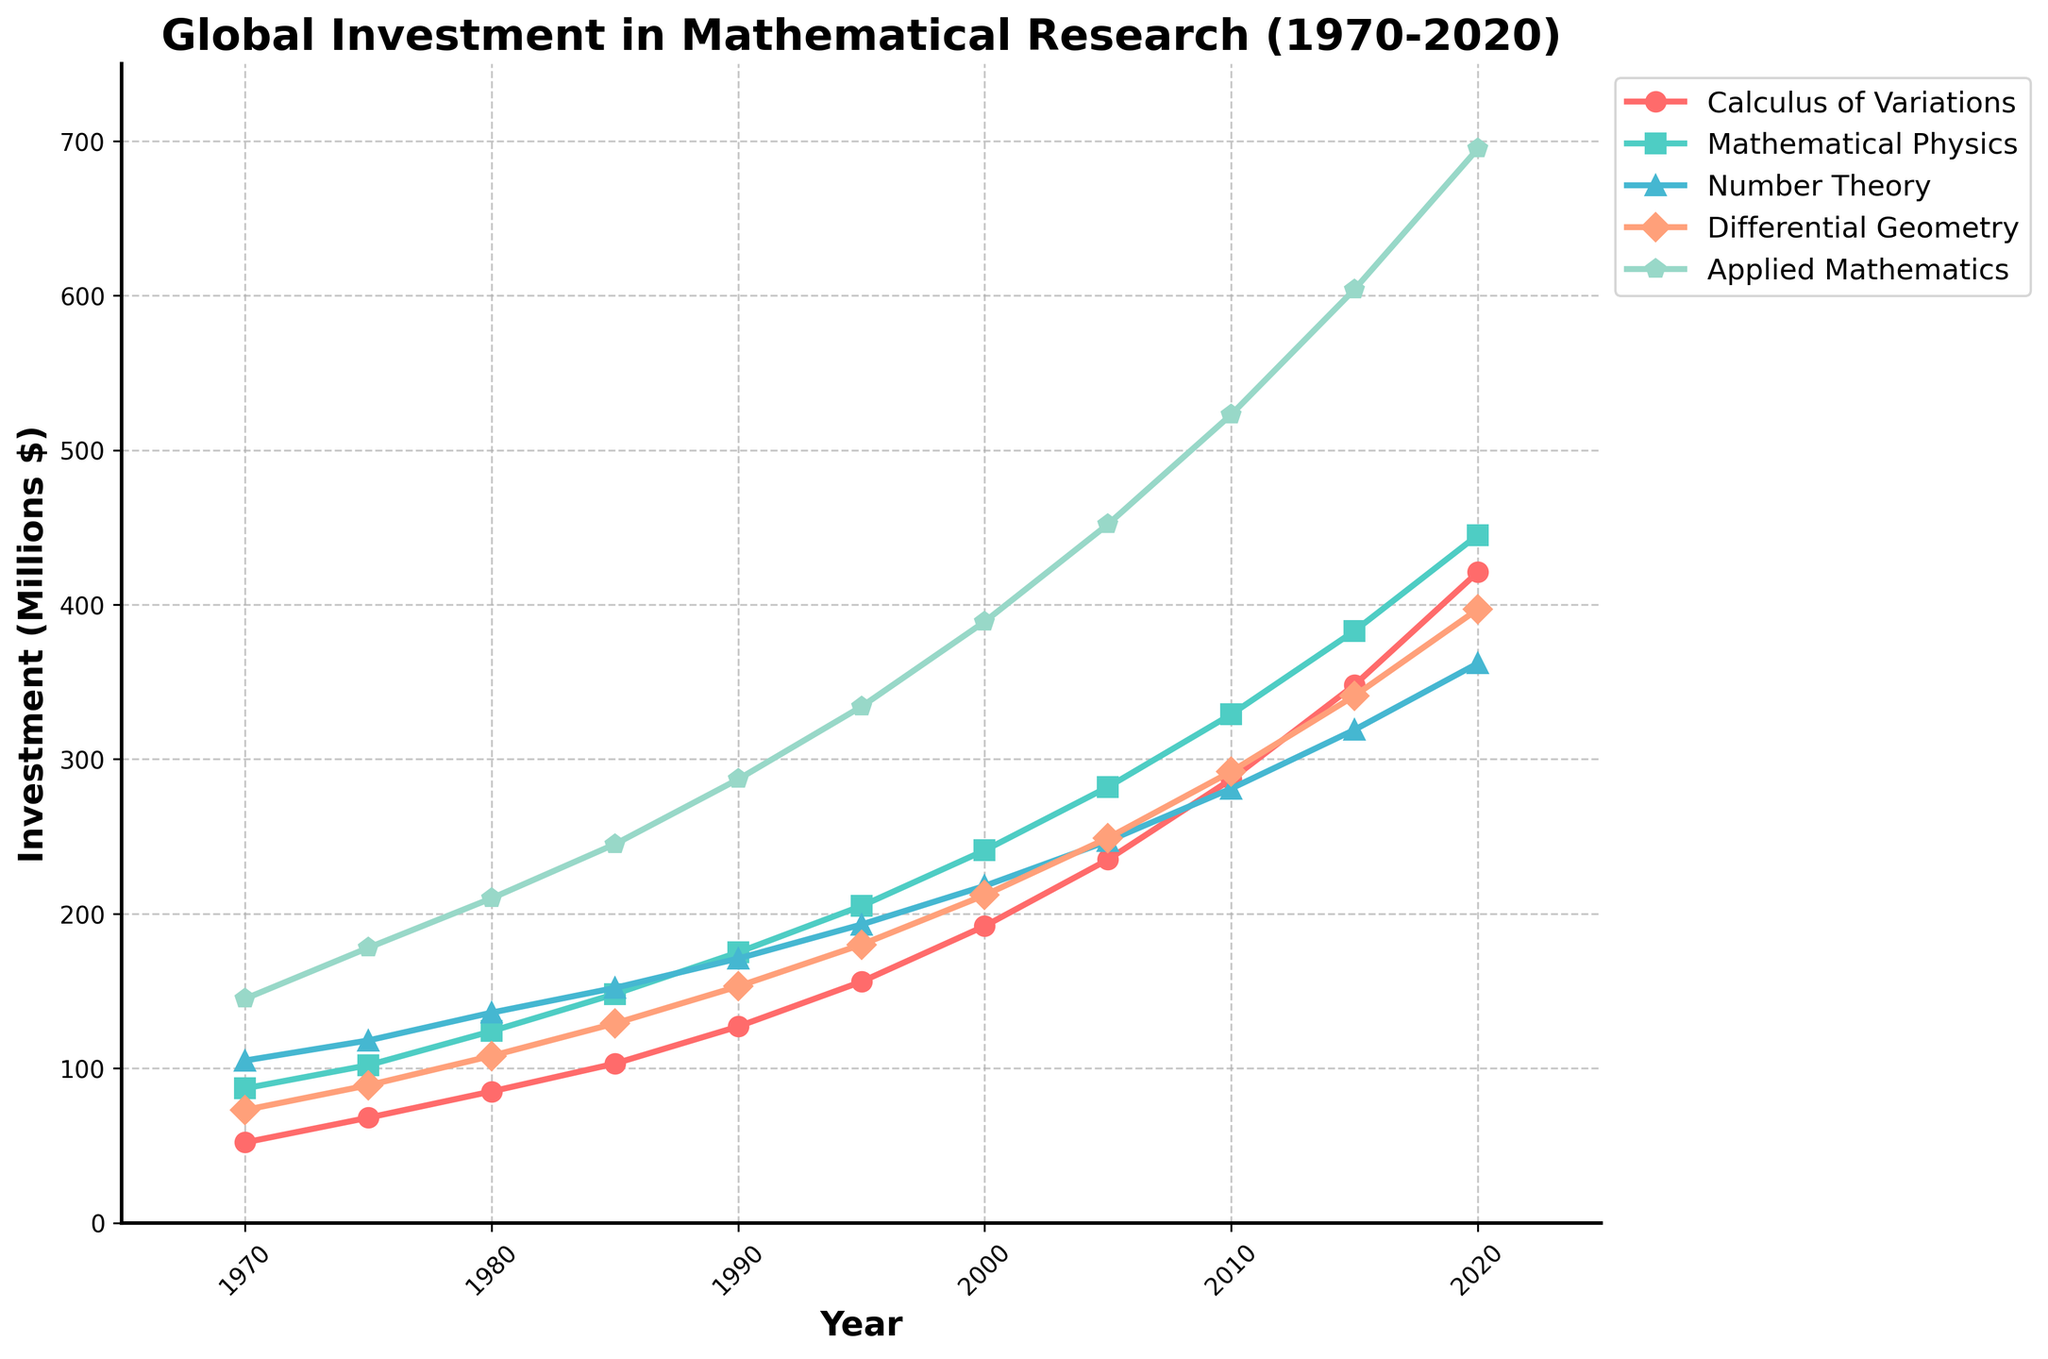What year did the investment in Calculus of Variations exceed 400 million dollars? According to the chart, the investment in Calculus of Variations exceeded 400 million dollars in the year 2020.
Answer: 2020 Which subfield had the highest investment in 2015? By looking at the height of the lines in 2015, the subfield with the highest investment is Applied Mathematics.
Answer: Applied Mathematics How does the investment in Mathematical Physics in 1980 compare to that in 1990? In 1980, the investment in Mathematical Physics was around 124 million dollars, while in 1990, it was around 175 million dollars. Thus, the investment increased by 51 million dollars.
Answer: Increased by 51 million dollars What is the difference in investment between Number Theory and Differential Geometry in 2000? The investment in Number Theory in 2000 was 218 million dollars, and in Differential Geometry, it was 212 million dollars. The difference is 218 - 212 equals 6 million dollars.
Answer: 6 million dollars Which subfield had the lowest investment in 1975, and how much was it? By checking the height of the lines in 1975, Differential Geometry had the lowest investment, which was 89 million dollars.
Answer: Differential Geometry, 89 million dollars What is the average investment in Calculus of Variations over the entire period? Adding up the investments from 1970 to 2020: 52 + 68 + 85 + 103 + 127 + 156 + 192 + 235 + 287 + 348 + 421 equals 2074 million dollars. Dividing this by 11 gives an average of approximately 188.5 million dollars.
Answer: 188.5 million dollars Compare the trend lines of Applied Mathematics and Number Theory from 1970 to 2020. Which one shows a steeper increase? From the chart, the line for Applied Mathematics grows faster than that for Number Theory over the period, indicating a steeper increase in investment.
Answer: Applied Mathematics Which subfield shows the smallest change in investment between 2010 and 2015? From 2010 to 2015, Number Theory shows the smallest change in investment, as the line's slope is gentler compared to the other subfields.
Answer: Number Theory What is the percentage increase in investment for Differential Geometry from 1990 to 2000? Investment in Differential Geometry in 1990 was 153 million dollars and in 2000 was 212 million dollars. The increase is 212 - 153 = 59 million dollars. The percentage increase is (59 / 153) * 100 ≈ 38.56%.
Answer: 38.56% Was there any year where investments in all subfields were less than 200 million dollars? Observing the lines, in 1970, investments in all subfields were less than 200 million dollars.
Answer: 1970 